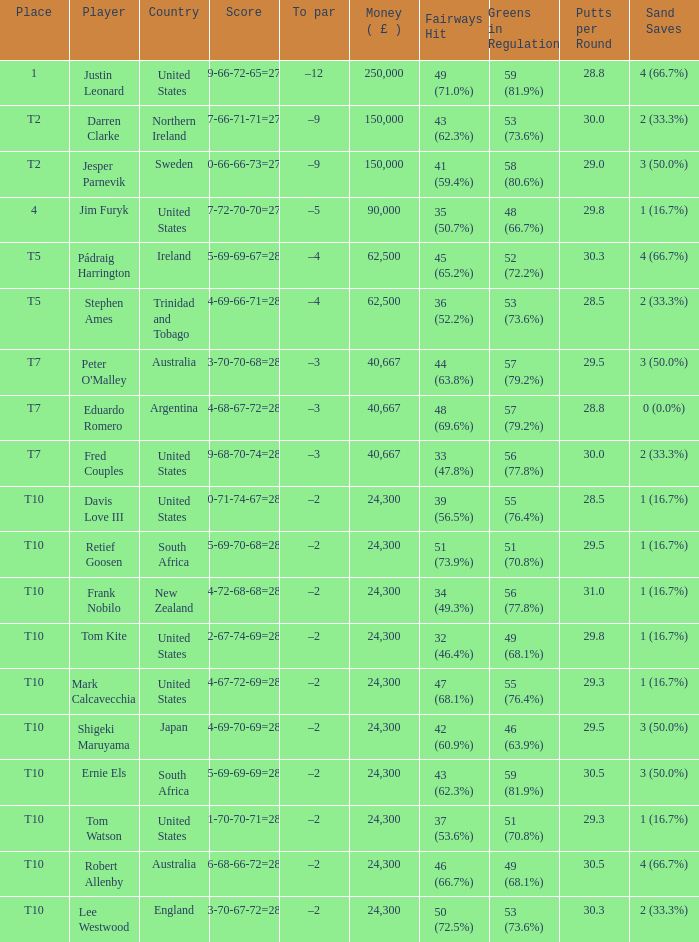What is the money won by Frank Nobilo? 1.0. 